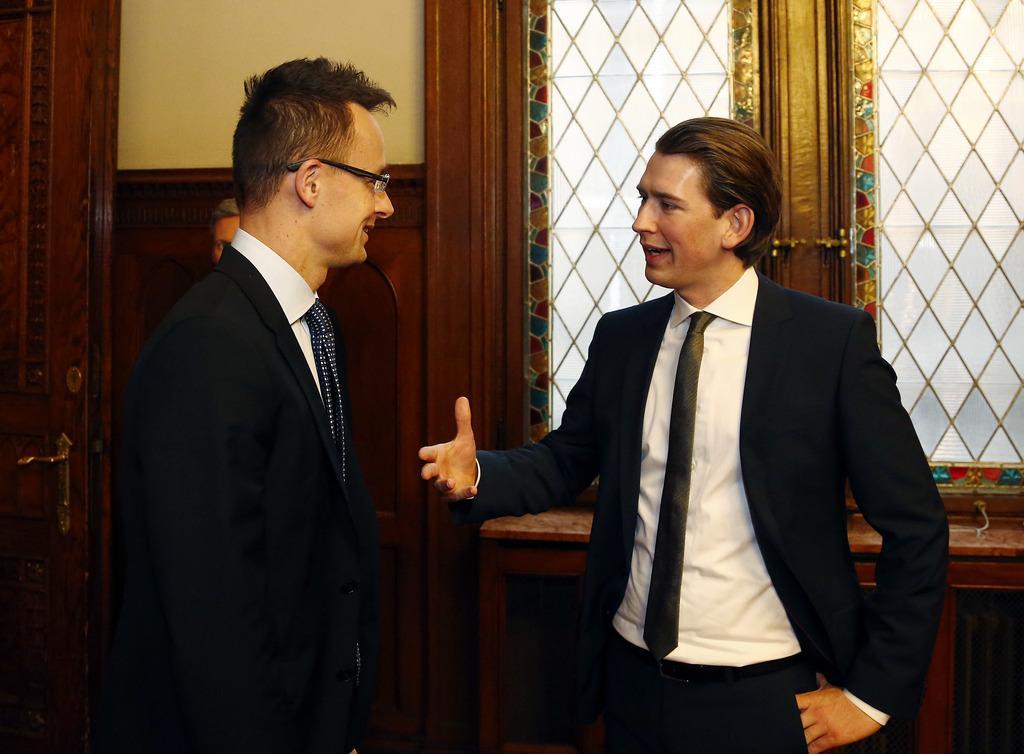Describe this image in one or two sentences. In this image we can see three persons, also we can see the wall, windows, and a door. 